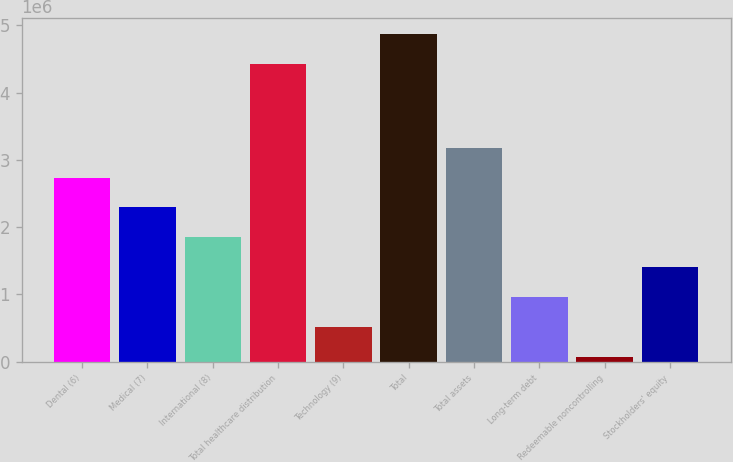Convert chart to OTSL. <chart><loc_0><loc_0><loc_500><loc_500><bar_chart><fcel>Dental (6)<fcel>Medical (7)<fcel>International (8)<fcel>Total healthcare distribution<fcel>Technology (9)<fcel>Total<fcel>Total assets<fcel>Long-term debt<fcel>Redeemable noncontrolling<fcel>Stockholders' equity<nl><fcel>2.73685e+06<fcel>2.29278e+06<fcel>1.84871e+06<fcel>4.42487e+06<fcel>516502<fcel>4.86894e+06<fcel>3.18092e+06<fcel>960572<fcel>72433<fcel>1.40464e+06<nl></chart> 